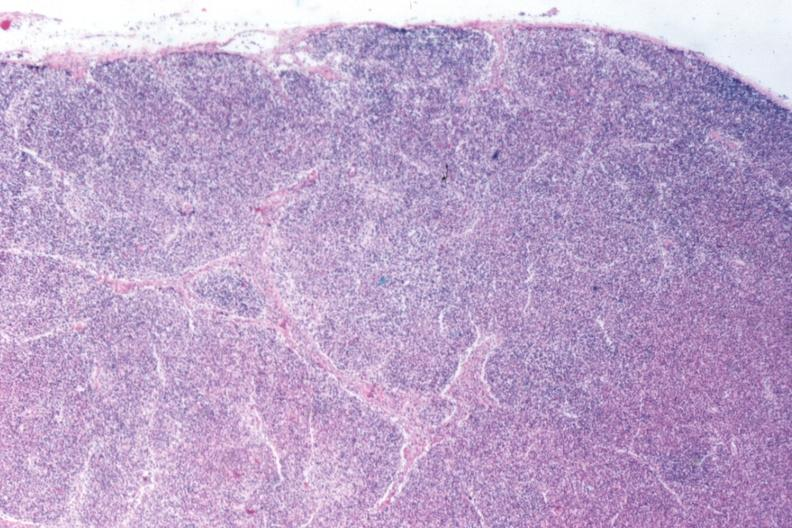what does total effacement case appear?
Answer the question using a single word or phrase. To have changed into a blast crisis 